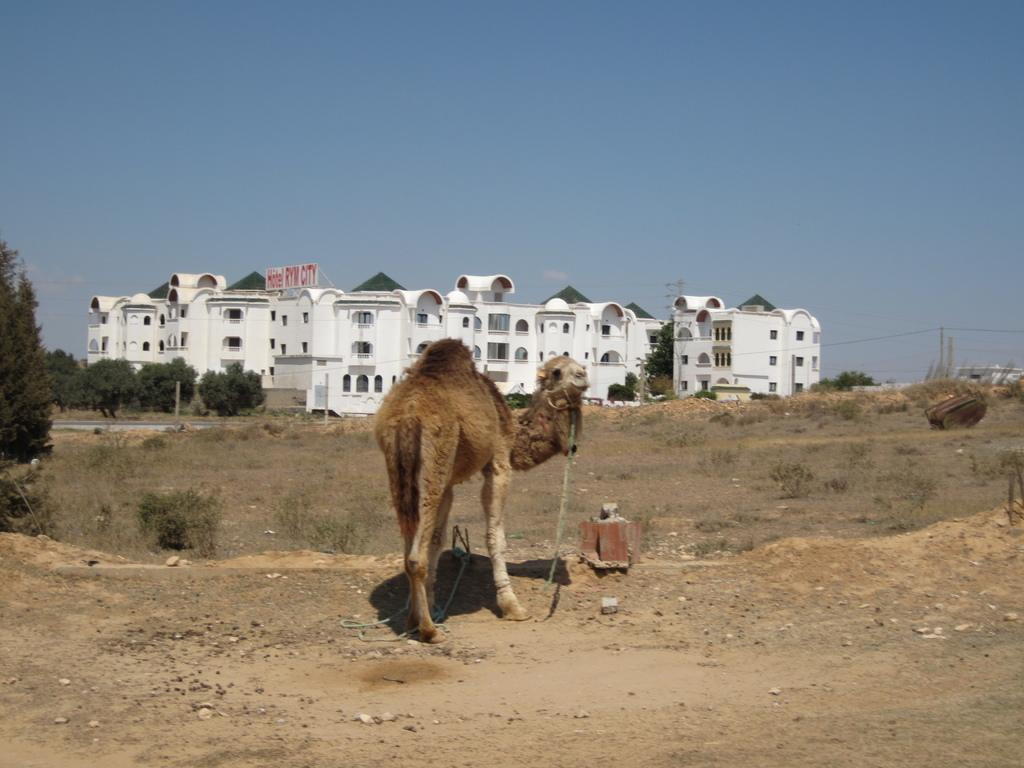What animal is the main subject of the image? There is a camel in the image. Where is the camel located? The camel is on a land. What can be seen in the background of the image? There are trees, buildings, and the sky visible in the background of the image. What type of pet can be seen sitting on the camel's back in the image? There is no pet visible on the camel's back in the image. What color is the horse's lip in the image? There is no horse present in the image, so it is not possible to determine the color of its lip. 